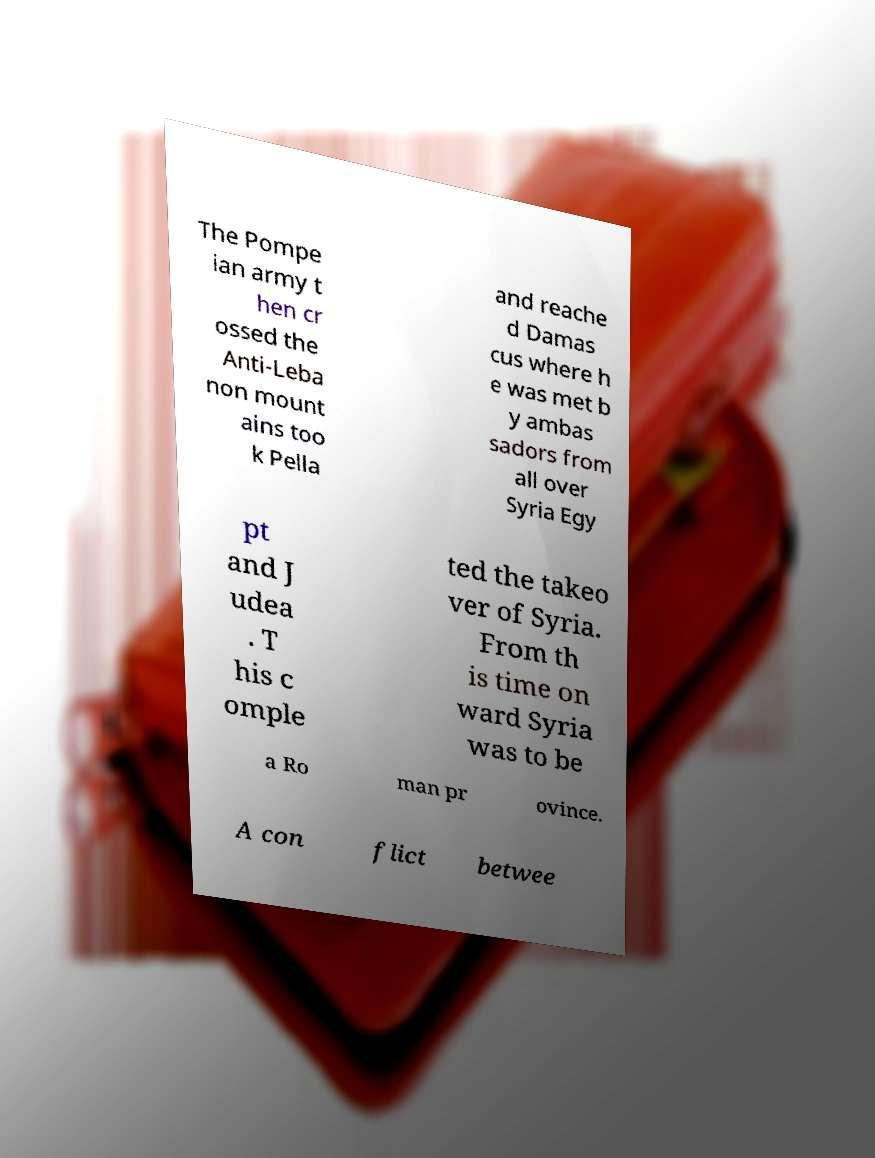Please read and relay the text visible in this image. What does it say? The Pompe ian army t hen cr ossed the Anti-Leba non mount ains too k Pella and reache d Damas cus where h e was met b y ambas sadors from all over Syria Egy pt and J udea . T his c omple ted the takeo ver of Syria. From th is time on ward Syria was to be a Ro man pr ovince. A con flict betwee 